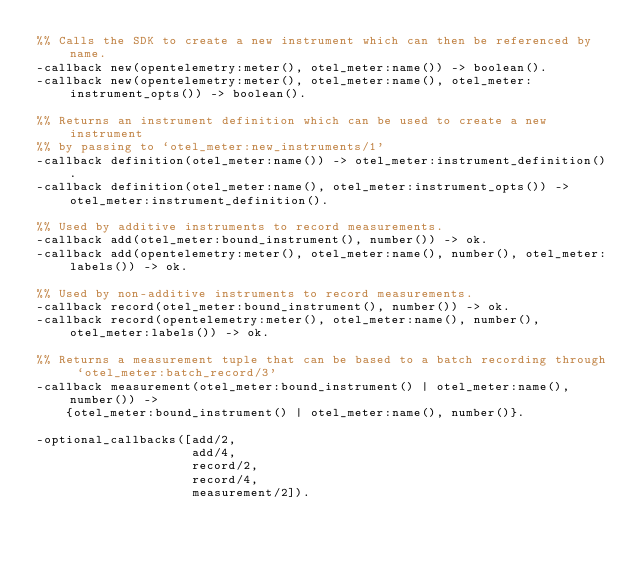Convert code to text. <code><loc_0><loc_0><loc_500><loc_500><_Erlang_>%% Calls the SDK to create a new instrument which can then be referenced by name.
-callback new(opentelemetry:meter(), otel_meter:name()) -> boolean().
-callback new(opentelemetry:meter(), otel_meter:name(), otel_meter:instrument_opts()) -> boolean().

%% Returns an instrument definition which can be used to create a new instrument
%% by passing to `otel_meter:new_instruments/1'
-callback definition(otel_meter:name()) -> otel_meter:instrument_definition().
-callback definition(otel_meter:name(), otel_meter:instrument_opts()) -> otel_meter:instrument_definition().

%% Used by additive instruments to record measurements.
-callback add(otel_meter:bound_instrument(), number()) -> ok.
-callback add(opentelemetry:meter(), otel_meter:name(), number(), otel_meter:labels()) -> ok.

%% Used by non-additive instruments to record measurements.
-callback record(otel_meter:bound_instrument(), number()) -> ok.
-callback record(opentelemetry:meter(), otel_meter:name(), number(), otel_meter:labels()) -> ok.

%% Returns a measurement tuple that can be based to a batch recording through `otel_meter:batch_record/3'
-callback measurement(otel_meter:bound_instrument() | otel_meter:name(), number()) ->
    {otel_meter:bound_instrument() | otel_meter:name(), number()}.

-optional_callbacks([add/2,
                     add/4,
                     record/2,
                     record/4,
                     measurement/2]).
</code> 